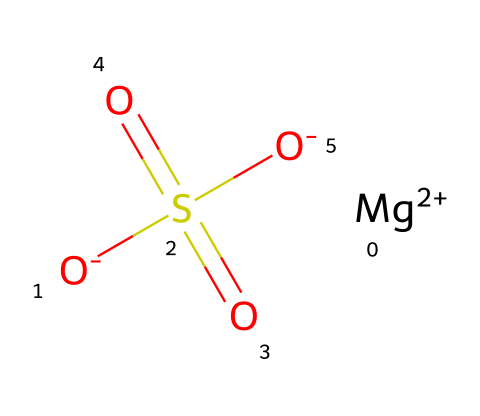What is the molecular formula of magnesium sulfate? The molecular formula can be derived from the SMILES representation by identifying the components: magnesium (Mg), sulfur (S), and oxygen (O). The representation indicates one magnesium ion, one sulfur atom, and four oxygen atoms, leading to the formula MgSO4.
Answer: MgSO4 How many oxygen atoms are present in magnesium sulfate? By analyzing the SMILES representation, one can count the number of oxygen atoms indicated by the O symbols. There are four oxygen atoms in the molecule.
Answer: 4 What is the oxidation state of magnesium in this compound? The oxidation state of magnesium can be determined from its charge in the representation, which shows a +2 charge. This indicates that magnesium has an oxidation state of +2 in this compound.
Answer: +2 How many sulfates are present in the structure of magnesium sulfate? The structure indicates there is one sulfate group, identifiable by the SO4 configuration within the representation, which reveals that sulfate = 1.
Answer: 1 What type of chemical bond exists between magnesium and sulfate in this compound? The bond between magnesium and sulfate can be inferred to be ionic, as magnesium (a metal) typically forms ionic bonds with sulfate (a polyatomic ion) due to the transfer of electrons.
Answer: ionic Why is magnesium sulfate considered an electrolyte? Magnesium sulfate dissociates into magnesium and sulfate ions when dissolved in water. The presence of these ions enables the conduction of electricity, classifying it as an electrolyte.
Answer: it dissociates into ions What applications does magnesium sulfate have beyond spa use? In addition to spa uses, magnesium sulfate is widely used in medicine, as a laxative, and as a treatment for eclampsia in pregnant women, indicating its diverse medicinal applications.
Answer: medicine 